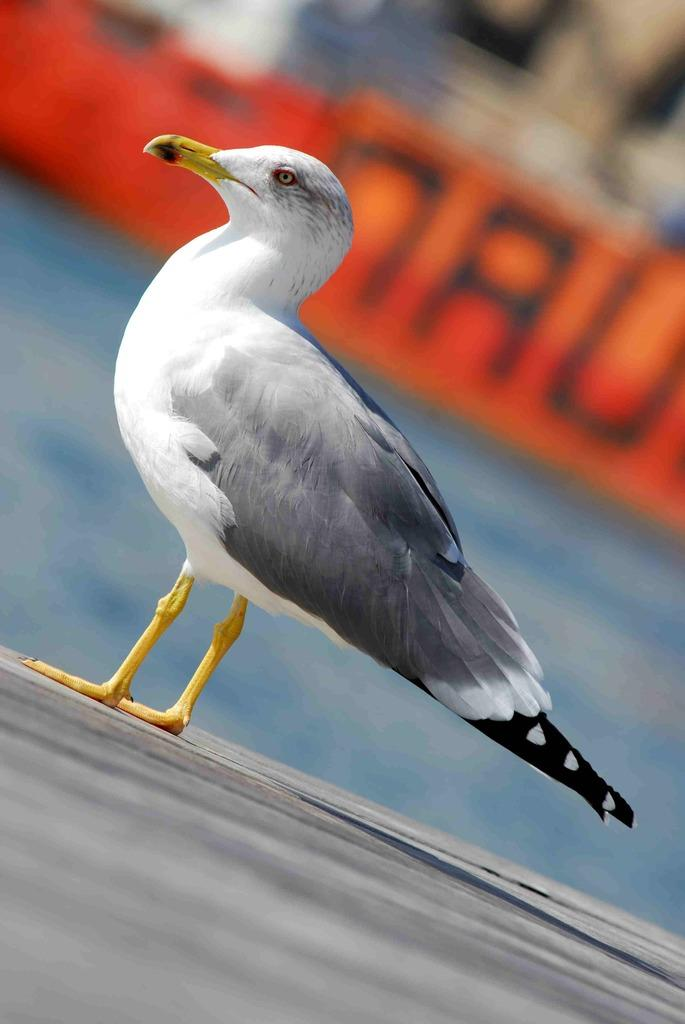What type of bird is in the image? There is a European herring gull in the image. What colors can be seen on the gull? The gull is white and black in color. What is the gull standing on in the image? The gull is standing on an object. What color is the background of the image? The background of the image is in orange color. What type of lipstick is the doll wearing in the image? There is no doll or lipstick present in the image; it features a European herring gull. 